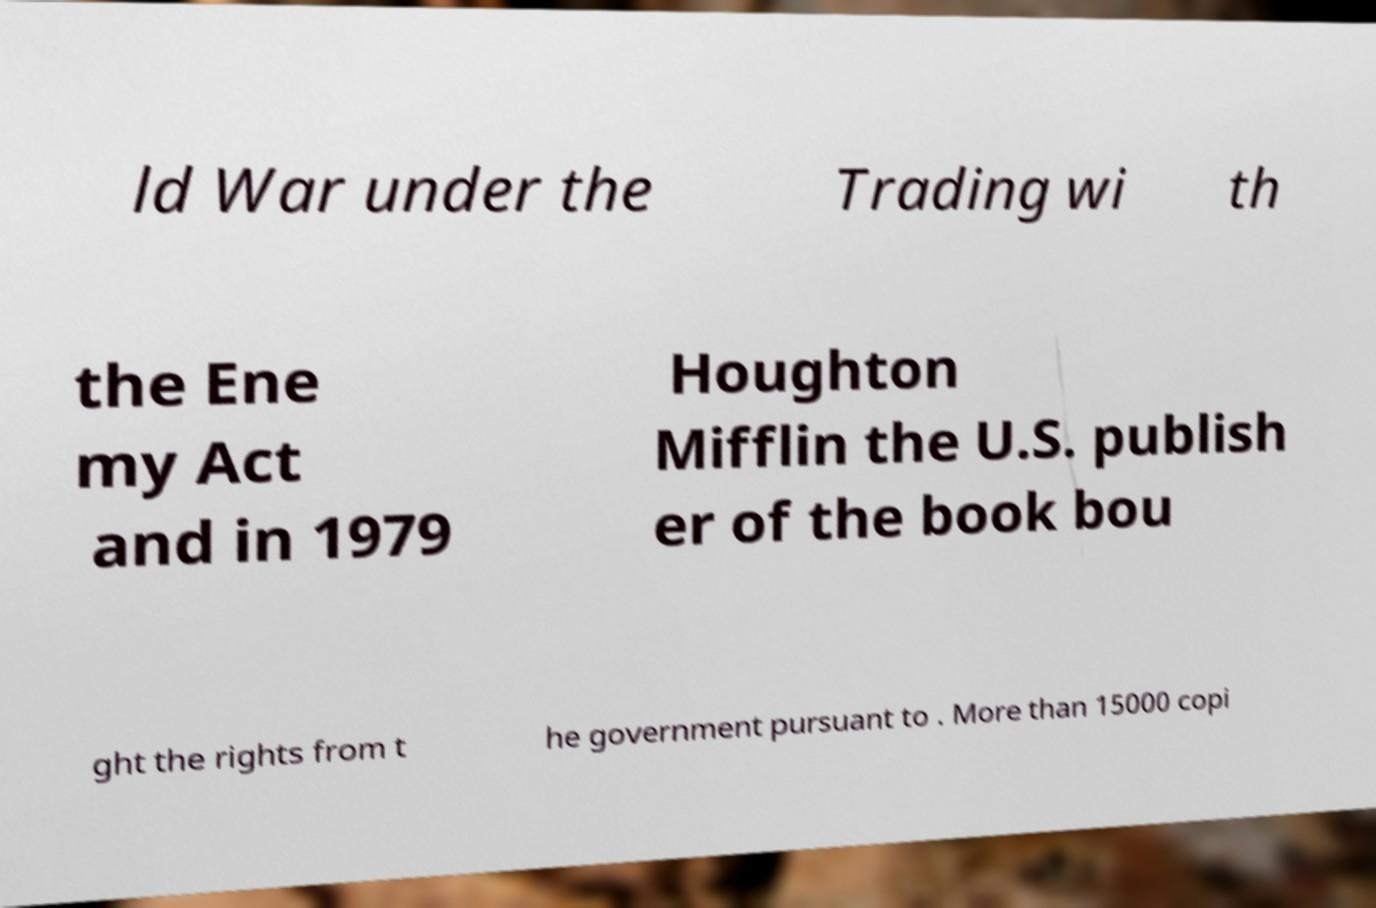Please identify and transcribe the text found in this image. ld War under the Trading wi th the Ene my Act and in 1979 Houghton Mifflin the U.S. publish er of the book bou ght the rights from t he government pursuant to . More than 15000 copi 